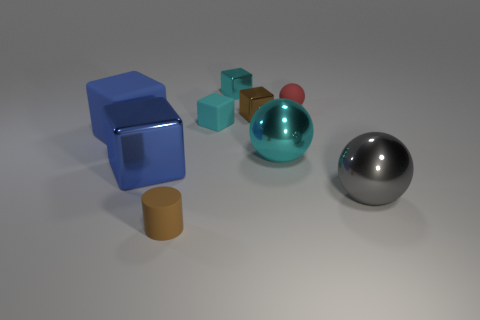What is the size of the blue rubber cube to the left of the tiny brown cylinder?
Your answer should be very brief. Large. What is the large cyan thing made of?
Offer a terse response. Metal. There is a matte object that is in front of the blue rubber cube; is its shape the same as the cyan rubber thing?
Provide a succinct answer. No. The metallic block that is the same color as the tiny cylinder is what size?
Offer a very short reply. Small. Is there a blue shiny thing that has the same size as the red matte sphere?
Your answer should be very brief. No. Are there any blue objects that are to the right of the tiny brown thing in front of the metal object that is right of the small red rubber thing?
Provide a succinct answer. No. There is a rubber cylinder; is its color the same as the matte cube that is right of the tiny cylinder?
Give a very brief answer. No. What material is the tiny block that is in front of the brown object that is behind the small thing that is in front of the gray metal sphere?
Your answer should be very brief. Rubber. What shape is the rubber thing that is behind the cyan rubber block?
Provide a succinct answer. Sphere. There is a brown object that is the same material as the large gray thing; what size is it?
Give a very brief answer. Small. 